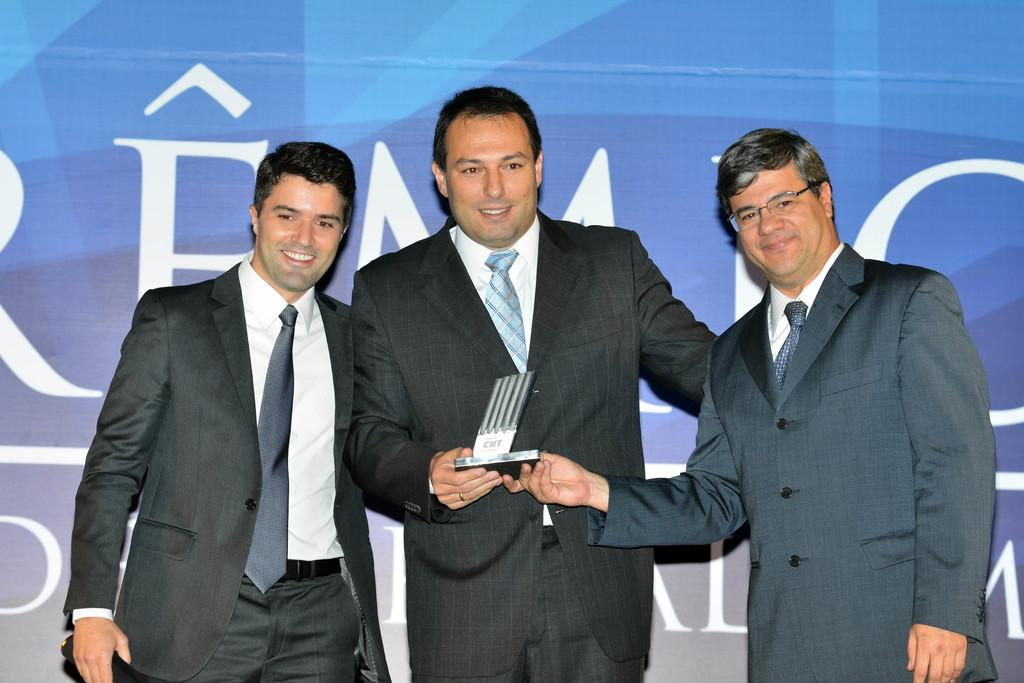How many men are in the image? There are three men in the image. What are the men doing in the image? The men are standing in the image. What are the men wearing in the image? The men are wearing clothes and ties in the image. Can you describe any objects in the image? Yes, there is an object, a finger ring, spectacles, and a poster in the image. What type of ray can be seen swimming in the image? There is no ray present in the image; it features three men standing and various objects. How much dust is visible on the poster in the image? There is no mention of dust in the image, and the poster's condition cannot be determined from the provided facts. 